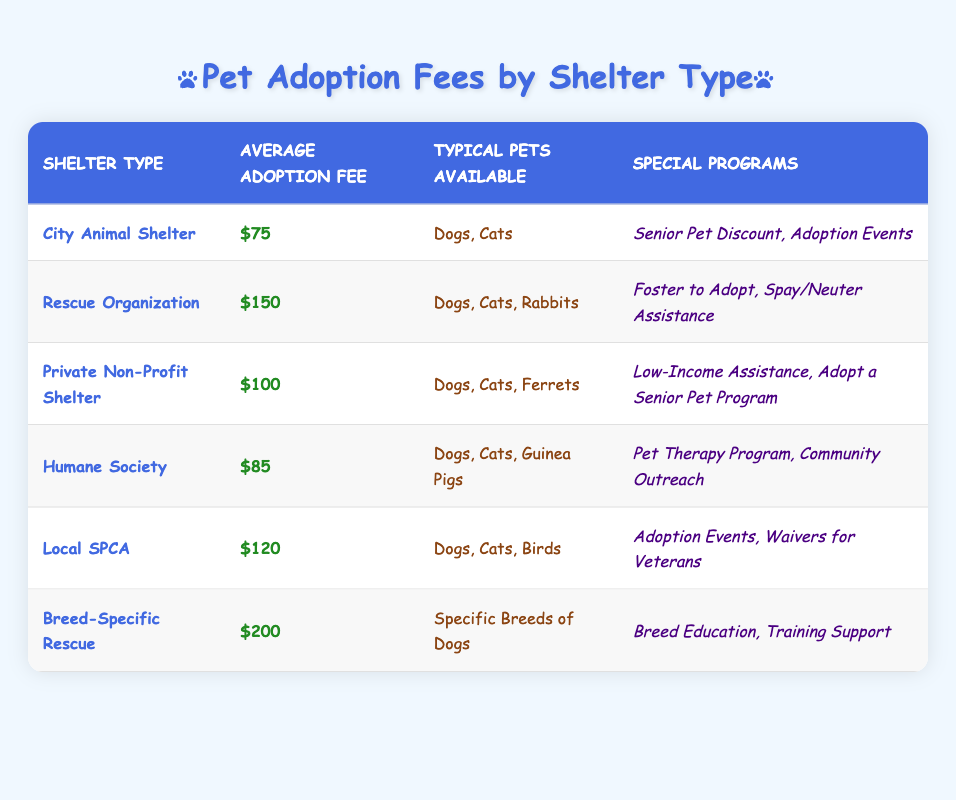What is the average adoption fee at the City Animal Shelter? The table indicates that the average adoption fee for the City Animal Shelter is $75.
Answer: $75 Which shelter has the highest average adoption fee? According to the table, the Breed-Specific Rescue has the highest average adoption fee at $200.
Answer: $200 What types of pets are available at the Local SPCA? The table shows that the Local SPCA offers Dogs, Cats, and Birds for adoption.
Answer: Dogs, Cats, Birds Are there any shelters that provide a Senior Pet Discount? The table reveals that the City Animal Shelter offers a Senior Pet Discount as one of their special programs.
Answer: Yes What is the difference in average adoption fees between the Rescue Organization and the Private Non-Profit Shelter? The average adoption fee for the Rescue Organization is $150, while the Private Non-Profit Shelter's fee is $100. The difference is $150 - $100 = $50.
Answer: $50 How much is the average adoption fee for shelters that provide spay/neuter assistance programs? The only shelter with a spay/neuter assistance program is the Rescue Organization, which has an average fee of $150. Since it is the only one, the average is simply $150.
Answer: $150 List the special programs available at the Humane Society. The table states that the Humane Society has two special programs: the Pet Therapy Program and Community Outreach.
Answer: Pet Therapy Program, Community Outreach What is the median average adoption fee across all shelters? First, we need the average fees: $75, $150, $100, $85, $120, $200. Ordering these, we have: $75, $85, $100, $120, $150, $200. The median of six values is the average of the 3rd ($100) and 4th ($120) values: (100 + 120) / 2 = $110.
Answer: $110 Do all shelters provide adoption events? The table indicates that only the City Animal Shelter, Local SPCA, and the Humane Society specifically list adoption events as part of their special programs. Therefore, not all shelters provide them.
Answer: No Which shelter has programs specifically for low-income families? The table shows that the Private Non-Profit Shelter offers programs for low-income assistance.
Answer: Private Non-Profit Shelter 